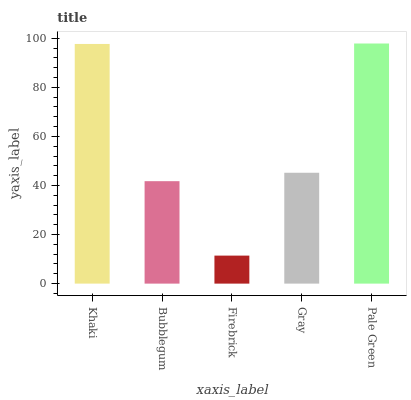Is Firebrick the minimum?
Answer yes or no. Yes. Is Pale Green the maximum?
Answer yes or no. Yes. Is Bubblegum the minimum?
Answer yes or no. No. Is Bubblegum the maximum?
Answer yes or no. No. Is Khaki greater than Bubblegum?
Answer yes or no. Yes. Is Bubblegum less than Khaki?
Answer yes or no. Yes. Is Bubblegum greater than Khaki?
Answer yes or no. No. Is Khaki less than Bubblegum?
Answer yes or no. No. Is Gray the high median?
Answer yes or no. Yes. Is Gray the low median?
Answer yes or no. Yes. Is Khaki the high median?
Answer yes or no. No. Is Khaki the low median?
Answer yes or no. No. 